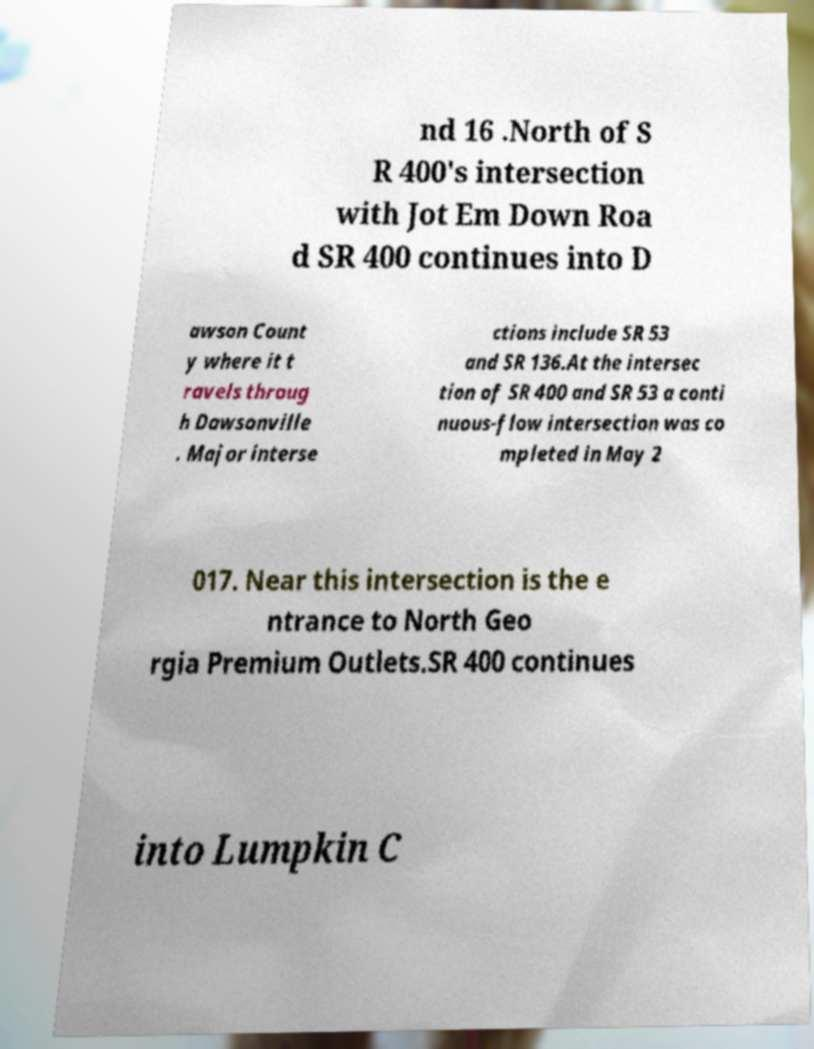Please identify and transcribe the text found in this image. nd 16 .North of S R 400's intersection with Jot Em Down Roa d SR 400 continues into D awson Count y where it t ravels throug h Dawsonville . Major interse ctions include SR 53 and SR 136.At the intersec tion of SR 400 and SR 53 a conti nuous-flow intersection was co mpleted in May 2 017. Near this intersection is the e ntrance to North Geo rgia Premium Outlets.SR 400 continues into Lumpkin C 